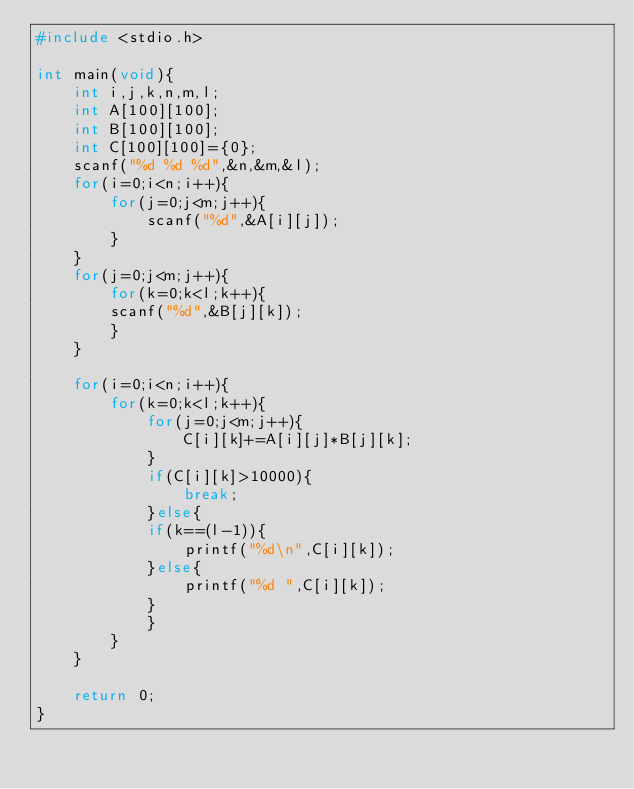Convert code to text. <code><loc_0><loc_0><loc_500><loc_500><_C_>#include <stdio.h>

int main(void){
	int i,j,k,n,m,l;
	int A[100][100];
	int B[100][100];
	int C[100][100]={0};
	scanf("%d %d %d",&n,&m,&l);
	for(i=0;i<n;i++){
		for(j=0;j<m;j++){
			scanf("%d",&A[i][j]);
		}
	}
	for(j=0;j<m;j++){
		for(k=0;k<l;k++){
		scanf("%d",&B[j][k]);
		}
	}

	for(i=0;i<n;i++){
		for(k=0;k<l;k++){
			for(j=0;j<m;j++){
				C[i][k]+=A[i][j]*B[j][k];
			}
			if(C[i][k]>10000){
				break;
			}else{
			if(k==(l-1)){
				printf("%d\n",C[i][k]);
			}else{
				printf("%d ",C[i][k]);
			}
			}
		}
	}

	return 0;
}</code> 